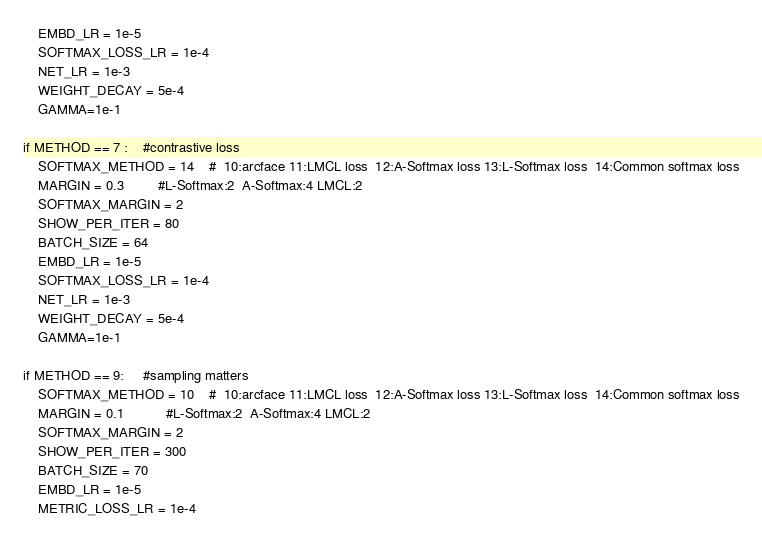Convert code to text. <code><loc_0><loc_0><loc_500><loc_500><_Python_>	EMBD_LR = 1e-5
	SOFTMAX_LOSS_LR = 1e-4
	NET_LR = 1e-3
	WEIGHT_DECAY = 5e-4
	GAMMA=1e-1

if METHOD == 7 :    #contrastive loss
	SOFTMAX_METHOD = 14    #  10:arcface 11:LMCL loss  12:A-Softmax loss 13:L-Softmax loss  14:Common softmax loss
	MARGIN = 0.3         #L-Softmax:2  A-Softmax:4 LMCL:2
	SOFTMAX_MARGIN = 2
	SHOW_PER_ITER = 80
	BATCH_SIZE = 64
	EMBD_LR = 1e-5
	SOFTMAX_LOSS_LR = 1e-4
	NET_LR = 1e-3
	WEIGHT_DECAY = 5e-4
	GAMMA=1e-1

if METHOD == 9:     #sampling matters
	SOFTMAX_METHOD = 10    #  10:arcface 11:LMCL loss  12:A-Softmax loss 13:L-Softmax loss  14:Common softmax loss
	MARGIN = 0.1           #L-Softmax:2  A-Softmax:4 LMCL:2
	SOFTMAX_MARGIN = 2
	SHOW_PER_ITER = 300
	BATCH_SIZE = 70
	EMBD_LR = 1e-5
	METRIC_LOSS_LR = 1e-4</code> 